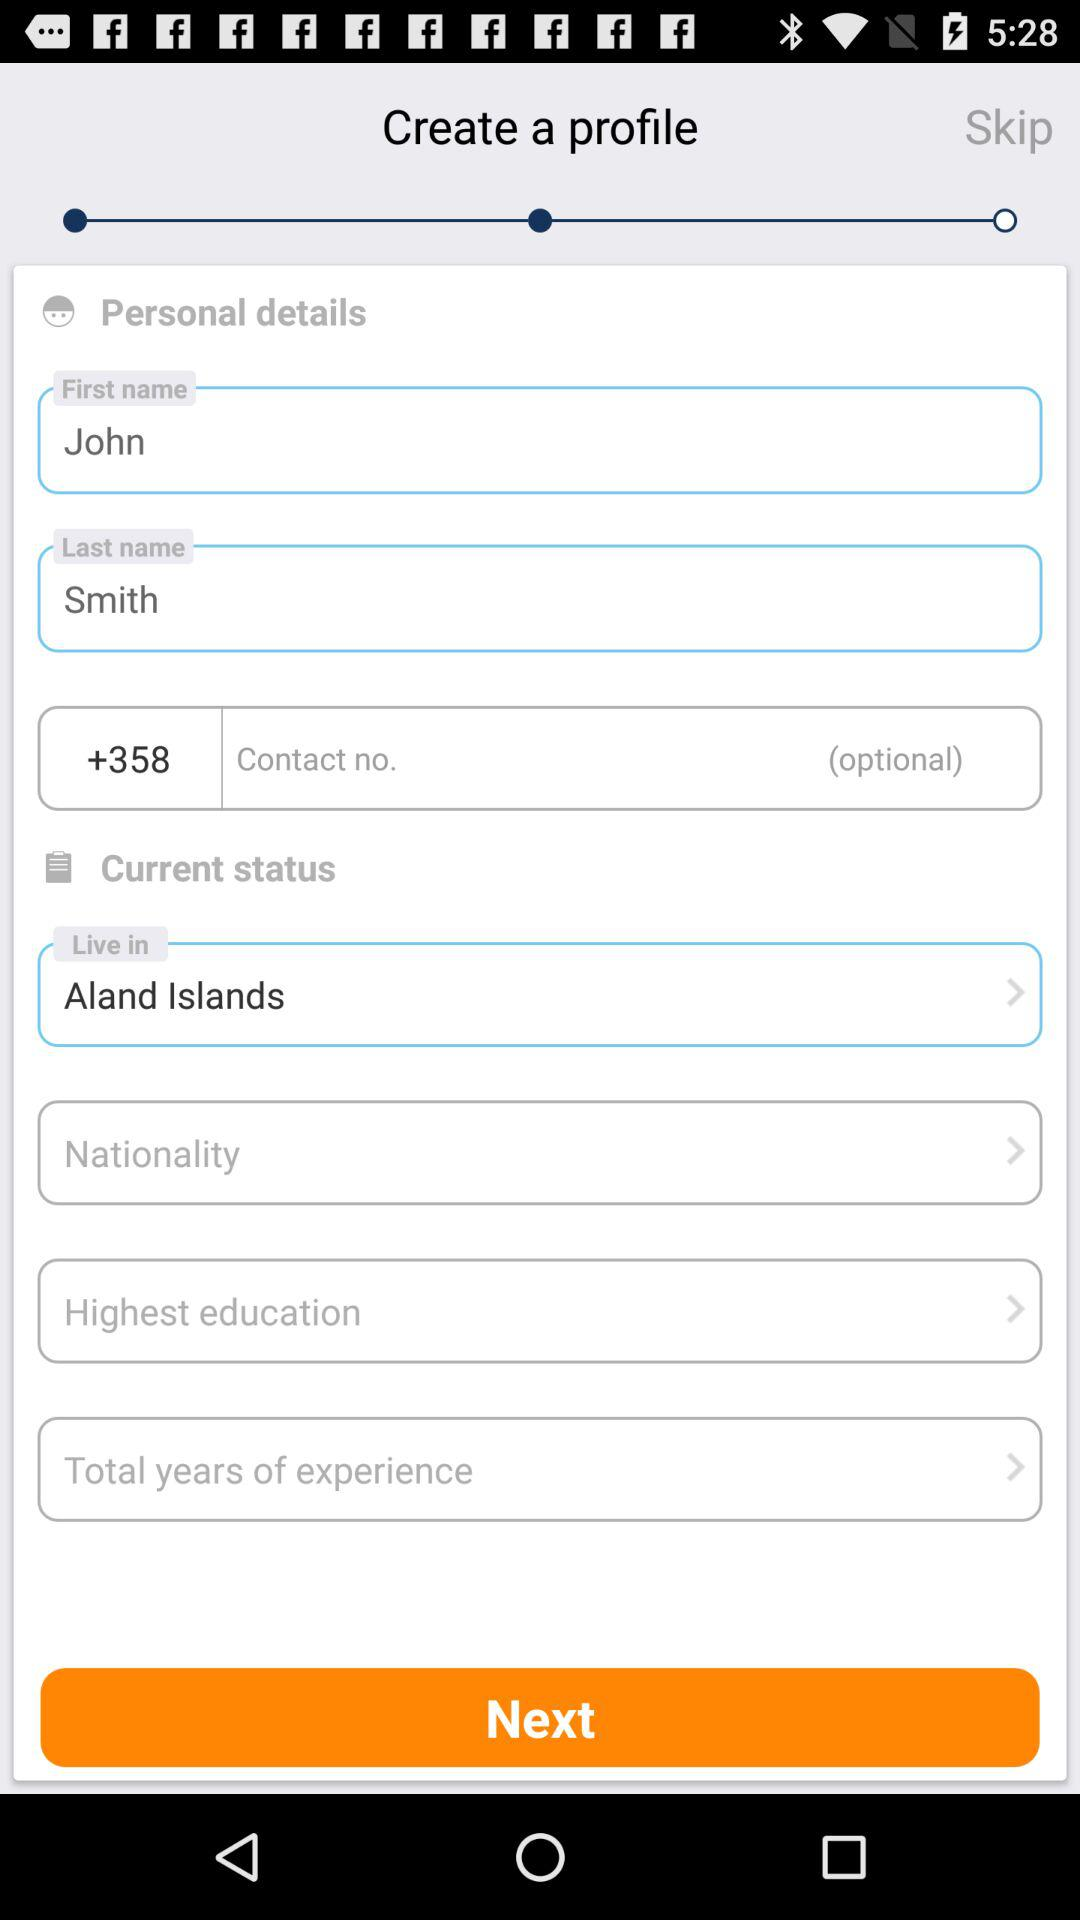What is the last name? The last name is Smith. 